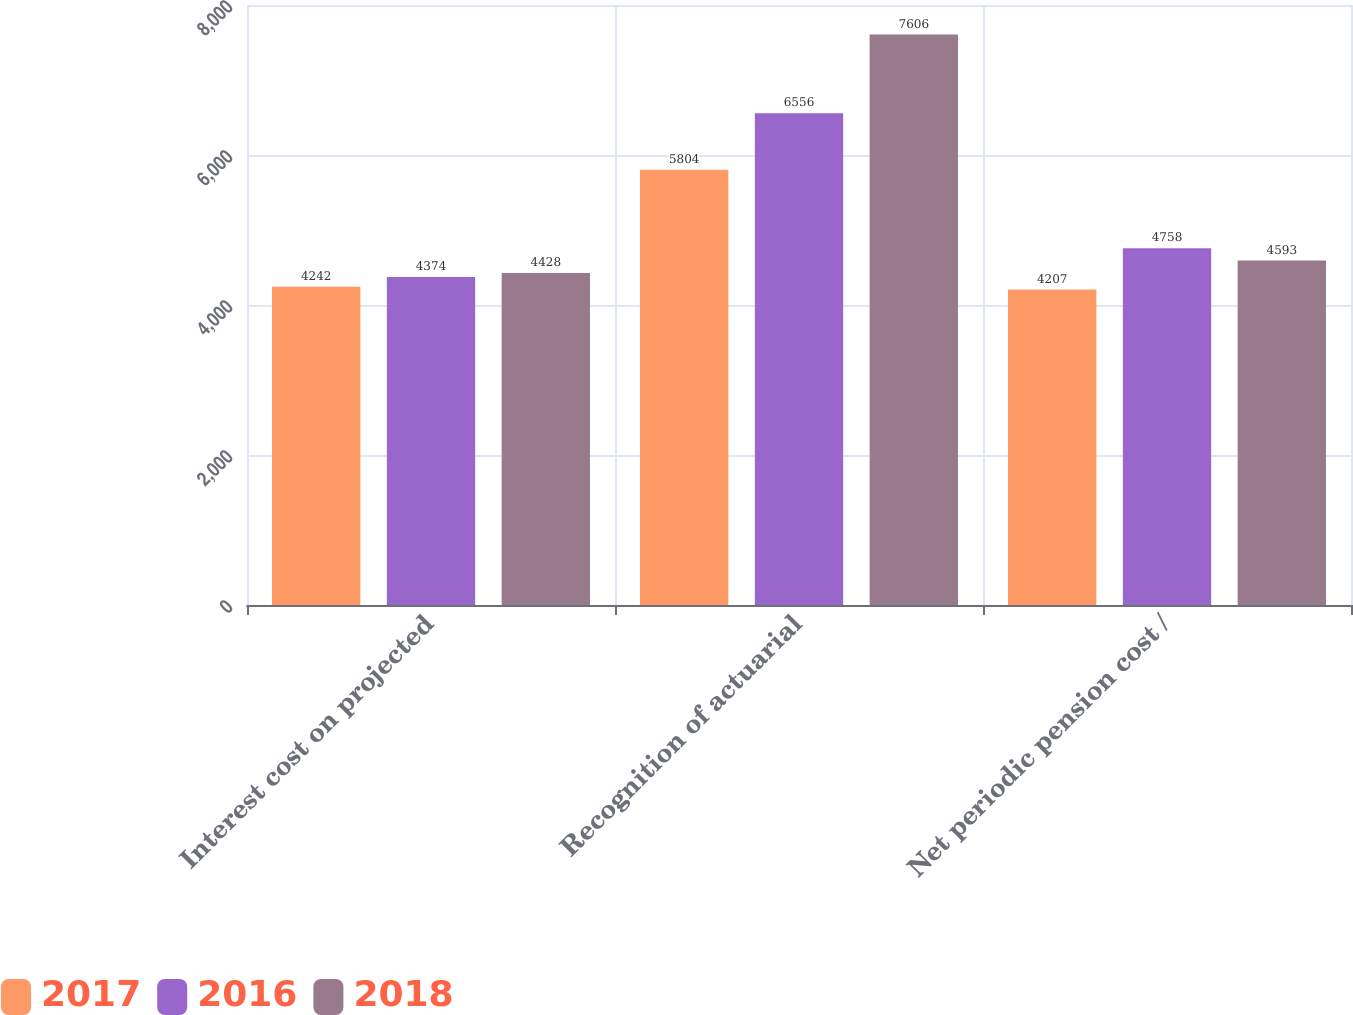Convert chart. <chart><loc_0><loc_0><loc_500><loc_500><stacked_bar_chart><ecel><fcel>Interest cost on projected<fcel>Recognition of actuarial<fcel>Net periodic pension cost /<nl><fcel>2017<fcel>4242<fcel>5804<fcel>4207<nl><fcel>2016<fcel>4374<fcel>6556<fcel>4758<nl><fcel>2018<fcel>4428<fcel>7606<fcel>4593<nl></chart> 